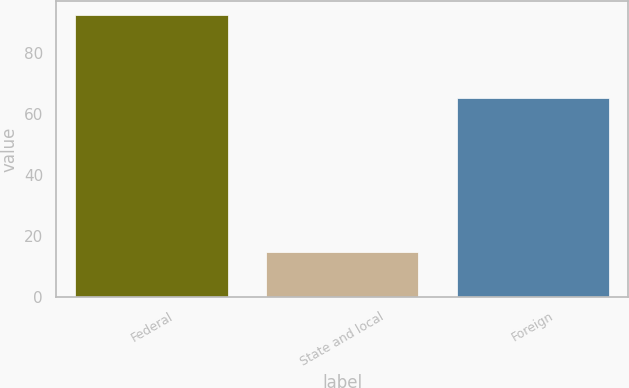Convert chart to OTSL. <chart><loc_0><loc_0><loc_500><loc_500><bar_chart><fcel>Federal<fcel>State and local<fcel>Foreign<nl><fcel>92.5<fcel>14.8<fcel>65.2<nl></chart> 